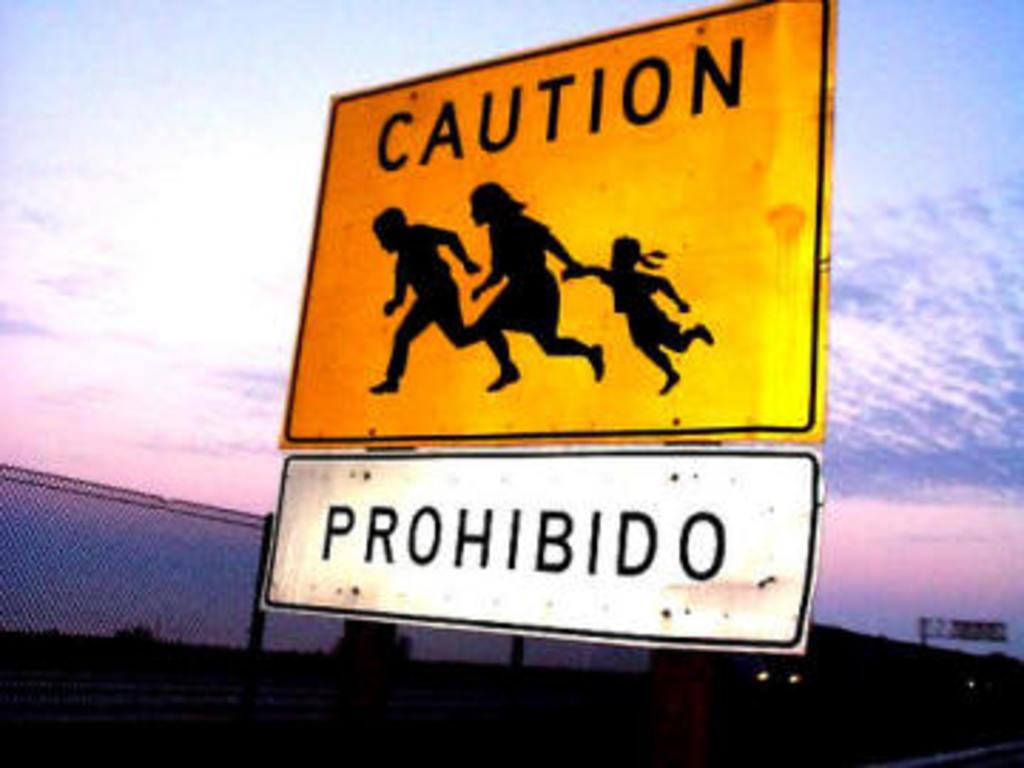What does it say on the white sign?
Offer a very short reply. Prohibido. 